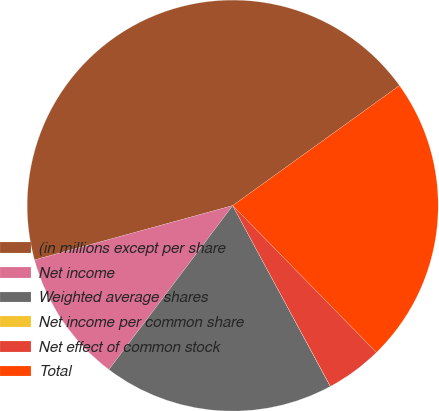<chart> <loc_0><loc_0><loc_500><loc_500><pie_chart><fcel>(in millions except per share<fcel>Net income<fcel>Weighted average shares<fcel>Net income per common share<fcel>Net effect of common stock<fcel>Total<nl><fcel>44.33%<fcel>10.45%<fcel>18.17%<fcel>0.01%<fcel>4.44%<fcel>22.6%<nl></chart> 